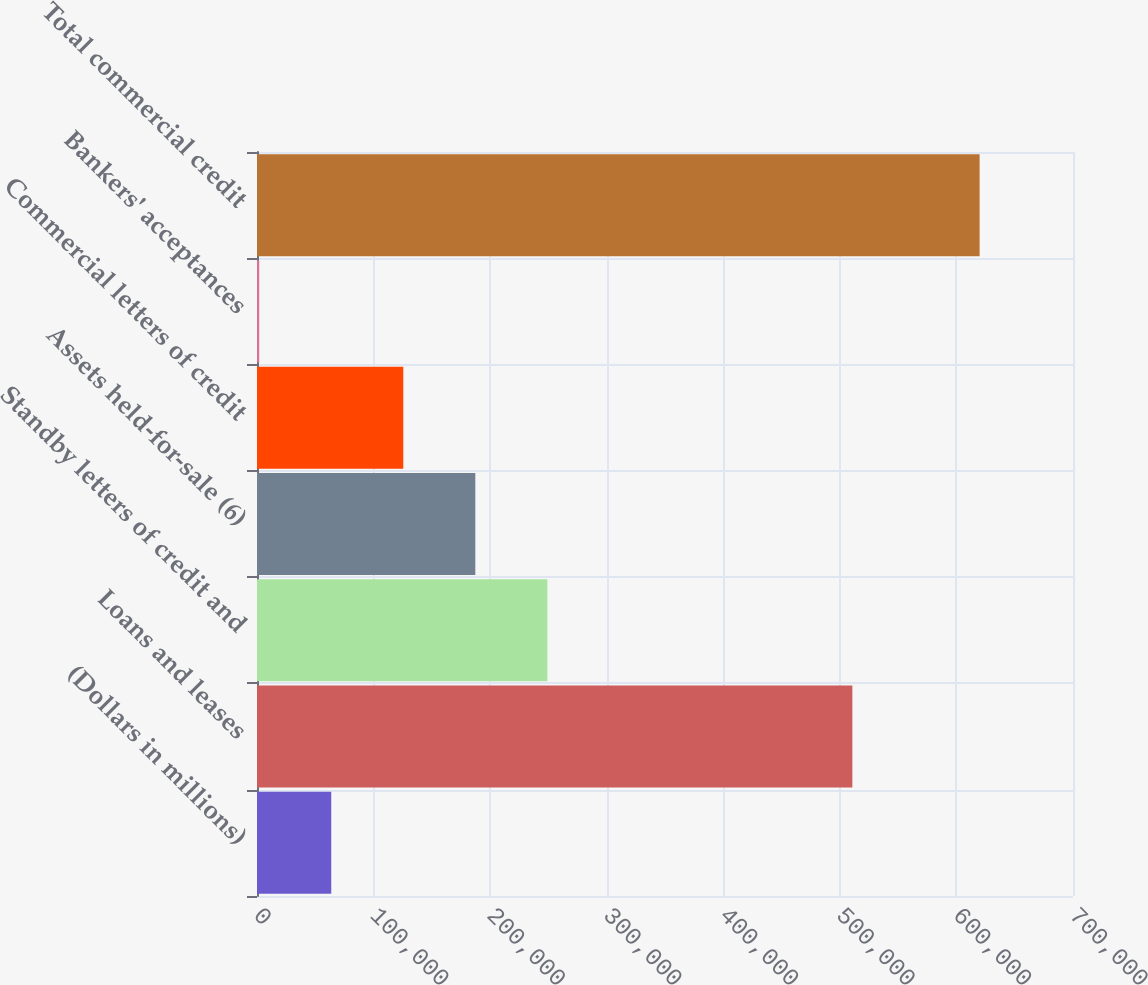Convert chart. <chart><loc_0><loc_0><loc_500><loc_500><bar_chart><fcel>(Dollars in millions)<fcel>Loans and leases<fcel>Standby letters of credit and<fcel>Assets held-for-sale (6)<fcel>Commercial letters of credit<fcel>Bankers' acceptances<fcel>Total commercial credit<nl><fcel>63685.1<fcel>510722<fcel>249082<fcel>187283<fcel>125484<fcel>1886<fcel>619877<nl></chart> 